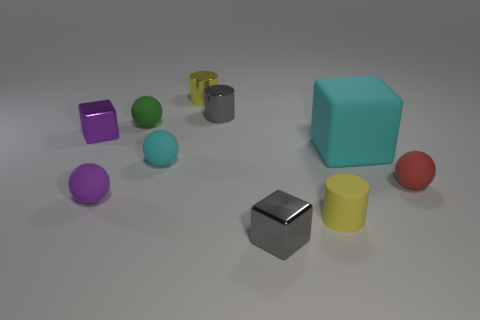Subtract 1 balls. How many balls are left? 3 Subtract all cylinders. How many objects are left? 7 Add 7 small rubber blocks. How many small rubber blocks exist? 7 Subtract 0 blue blocks. How many objects are left? 10 Subtract all shiny cylinders. Subtract all brown rubber spheres. How many objects are left? 8 Add 9 tiny gray cubes. How many tiny gray cubes are left? 10 